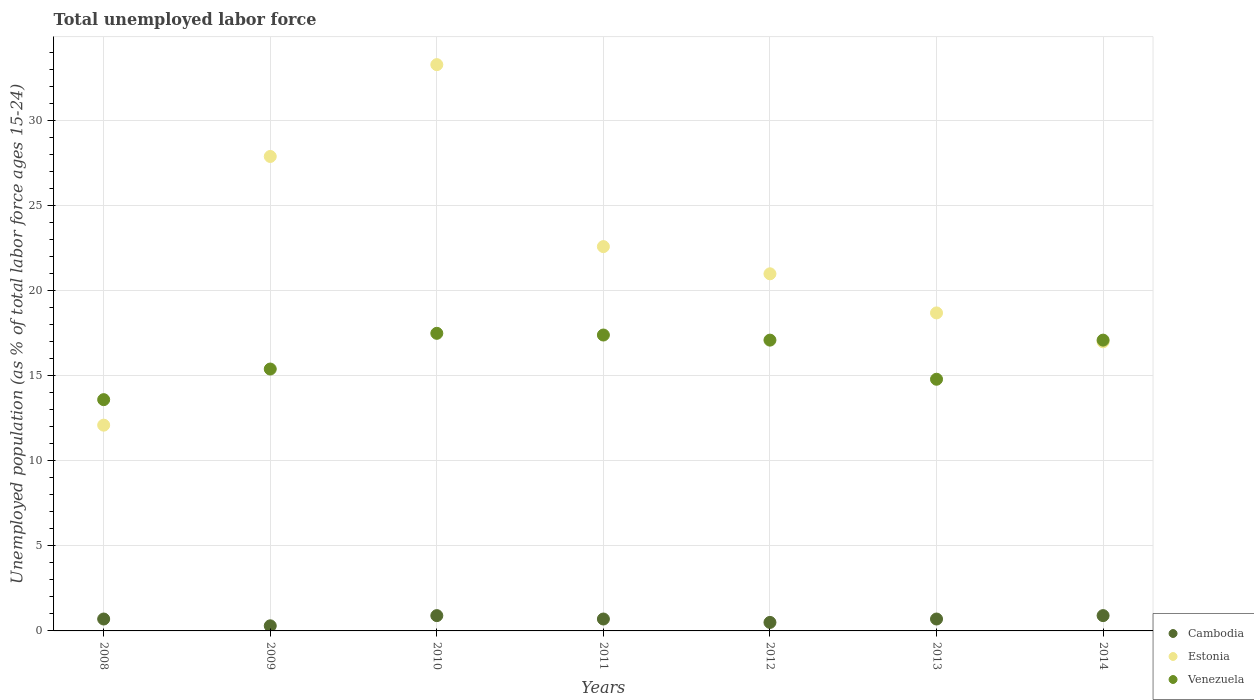Is the number of dotlines equal to the number of legend labels?
Offer a very short reply. Yes. Across all years, what is the maximum percentage of unemployed population in in Cambodia?
Offer a terse response. 0.9. Across all years, what is the minimum percentage of unemployed population in in Venezuela?
Provide a succinct answer. 13.6. In which year was the percentage of unemployed population in in Venezuela minimum?
Keep it short and to the point. 2008. What is the total percentage of unemployed population in in Estonia in the graph?
Offer a terse response. 152.6. What is the difference between the percentage of unemployed population in in Cambodia in 2009 and that in 2011?
Provide a succinct answer. -0.4. What is the difference between the percentage of unemployed population in in Estonia in 2008 and the percentage of unemployed population in in Venezuela in 2009?
Provide a short and direct response. -3.3. What is the average percentage of unemployed population in in Cambodia per year?
Keep it short and to the point. 0.67. In the year 2011, what is the difference between the percentage of unemployed population in in Venezuela and percentage of unemployed population in in Estonia?
Make the answer very short. -5.2. In how many years, is the percentage of unemployed population in in Venezuela greater than 12 %?
Provide a short and direct response. 7. What is the ratio of the percentage of unemployed population in in Cambodia in 2013 to that in 2014?
Provide a succinct answer. 0.78. Is the percentage of unemployed population in in Venezuela in 2011 less than that in 2012?
Make the answer very short. No. Is the difference between the percentage of unemployed population in in Venezuela in 2009 and 2010 greater than the difference between the percentage of unemployed population in in Estonia in 2009 and 2010?
Keep it short and to the point. Yes. What is the difference between the highest and the second highest percentage of unemployed population in in Cambodia?
Make the answer very short. 0. What is the difference between the highest and the lowest percentage of unemployed population in in Cambodia?
Your answer should be very brief. 0.6. In how many years, is the percentage of unemployed population in in Cambodia greater than the average percentage of unemployed population in in Cambodia taken over all years?
Your answer should be compact. 5. Is the sum of the percentage of unemployed population in in Estonia in 2010 and 2013 greater than the maximum percentage of unemployed population in in Venezuela across all years?
Keep it short and to the point. Yes. Is it the case that in every year, the sum of the percentage of unemployed population in in Venezuela and percentage of unemployed population in in Cambodia  is greater than the percentage of unemployed population in in Estonia?
Offer a very short reply. No. Is the percentage of unemployed population in in Venezuela strictly less than the percentage of unemployed population in in Cambodia over the years?
Ensure brevity in your answer.  No. How many years are there in the graph?
Provide a short and direct response. 7. What is the difference between two consecutive major ticks on the Y-axis?
Give a very brief answer. 5. Does the graph contain any zero values?
Offer a very short reply. No. Does the graph contain grids?
Ensure brevity in your answer.  Yes. Where does the legend appear in the graph?
Give a very brief answer. Bottom right. How are the legend labels stacked?
Your answer should be compact. Vertical. What is the title of the graph?
Make the answer very short. Total unemployed labor force. Does "Bahamas" appear as one of the legend labels in the graph?
Make the answer very short. No. What is the label or title of the X-axis?
Keep it short and to the point. Years. What is the label or title of the Y-axis?
Keep it short and to the point. Unemployed population (as % of total labor force ages 15-24). What is the Unemployed population (as % of total labor force ages 15-24) of Cambodia in 2008?
Your answer should be very brief. 0.7. What is the Unemployed population (as % of total labor force ages 15-24) of Estonia in 2008?
Make the answer very short. 12.1. What is the Unemployed population (as % of total labor force ages 15-24) of Venezuela in 2008?
Provide a succinct answer. 13.6. What is the Unemployed population (as % of total labor force ages 15-24) of Cambodia in 2009?
Provide a succinct answer. 0.3. What is the Unemployed population (as % of total labor force ages 15-24) of Estonia in 2009?
Offer a terse response. 27.9. What is the Unemployed population (as % of total labor force ages 15-24) of Venezuela in 2009?
Ensure brevity in your answer.  15.4. What is the Unemployed population (as % of total labor force ages 15-24) of Cambodia in 2010?
Offer a terse response. 0.9. What is the Unemployed population (as % of total labor force ages 15-24) in Estonia in 2010?
Ensure brevity in your answer.  33.3. What is the Unemployed population (as % of total labor force ages 15-24) of Venezuela in 2010?
Keep it short and to the point. 17.5. What is the Unemployed population (as % of total labor force ages 15-24) of Cambodia in 2011?
Keep it short and to the point. 0.7. What is the Unemployed population (as % of total labor force ages 15-24) in Estonia in 2011?
Keep it short and to the point. 22.6. What is the Unemployed population (as % of total labor force ages 15-24) in Venezuela in 2011?
Provide a succinct answer. 17.4. What is the Unemployed population (as % of total labor force ages 15-24) in Estonia in 2012?
Provide a succinct answer. 21. What is the Unemployed population (as % of total labor force ages 15-24) of Venezuela in 2012?
Give a very brief answer. 17.1. What is the Unemployed population (as % of total labor force ages 15-24) in Cambodia in 2013?
Give a very brief answer. 0.7. What is the Unemployed population (as % of total labor force ages 15-24) in Estonia in 2013?
Provide a succinct answer. 18.7. What is the Unemployed population (as % of total labor force ages 15-24) in Venezuela in 2013?
Your response must be concise. 14.8. What is the Unemployed population (as % of total labor force ages 15-24) in Cambodia in 2014?
Your response must be concise. 0.9. What is the Unemployed population (as % of total labor force ages 15-24) in Venezuela in 2014?
Your answer should be compact. 17.1. Across all years, what is the maximum Unemployed population (as % of total labor force ages 15-24) in Cambodia?
Your answer should be very brief. 0.9. Across all years, what is the maximum Unemployed population (as % of total labor force ages 15-24) in Estonia?
Provide a short and direct response. 33.3. Across all years, what is the maximum Unemployed population (as % of total labor force ages 15-24) in Venezuela?
Provide a succinct answer. 17.5. Across all years, what is the minimum Unemployed population (as % of total labor force ages 15-24) of Cambodia?
Provide a succinct answer. 0.3. Across all years, what is the minimum Unemployed population (as % of total labor force ages 15-24) in Estonia?
Offer a very short reply. 12.1. Across all years, what is the minimum Unemployed population (as % of total labor force ages 15-24) in Venezuela?
Your answer should be very brief. 13.6. What is the total Unemployed population (as % of total labor force ages 15-24) in Estonia in the graph?
Your answer should be very brief. 152.6. What is the total Unemployed population (as % of total labor force ages 15-24) in Venezuela in the graph?
Your answer should be very brief. 112.9. What is the difference between the Unemployed population (as % of total labor force ages 15-24) of Estonia in 2008 and that in 2009?
Your answer should be very brief. -15.8. What is the difference between the Unemployed population (as % of total labor force ages 15-24) in Estonia in 2008 and that in 2010?
Provide a succinct answer. -21.2. What is the difference between the Unemployed population (as % of total labor force ages 15-24) in Cambodia in 2008 and that in 2011?
Make the answer very short. 0. What is the difference between the Unemployed population (as % of total labor force ages 15-24) in Venezuela in 2008 and that in 2012?
Ensure brevity in your answer.  -3.5. What is the difference between the Unemployed population (as % of total labor force ages 15-24) of Estonia in 2008 and that in 2013?
Your answer should be very brief. -6.6. What is the difference between the Unemployed population (as % of total labor force ages 15-24) in Venezuela in 2008 and that in 2013?
Provide a short and direct response. -1.2. What is the difference between the Unemployed population (as % of total labor force ages 15-24) of Venezuela in 2008 and that in 2014?
Your answer should be compact. -3.5. What is the difference between the Unemployed population (as % of total labor force ages 15-24) of Estonia in 2009 and that in 2010?
Offer a very short reply. -5.4. What is the difference between the Unemployed population (as % of total labor force ages 15-24) of Venezuela in 2009 and that in 2010?
Provide a succinct answer. -2.1. What is the difference between the Unemployed population (as % of total labor force ages 15-24) of Cambodia in 2009 and that in 2011?
Keep it short and to the point. -0.4. What is the difference between the Unemployed population (as % of total labor force ages 15-24) of Estonia in 2009 and that in 2011?
Your answer should be very brief. 5.3. What is the difference between the Unemployed population (as % of total labor force ages 15-24) in Venezuela in 2009 and that in 2011?
Offer a terse response. -2. What is the difference between the Unemployed population (as % of total labor force ages 15-24) in Estonia in 2009 and that in 2012?
Offer a very short reply. 6.9. What is the difference between the Unemployed population (as % of total labor force ages 15-24) of Venezuela in 2009 and that in 2012?
Offer a terse response. -1.7. What is the difference between the Unemployed population (as % of total labor force ages 15-24) in Cambodia in 2009 and that in 2014?
Keep it short and to the point. -0.6. What is the difference between the Unemployed population (as % of total labor force ages 15-24) of Estonia in 2009 and that in 2014?
Your answer should be compact. 10.9. What is the difference between the Unemployed population (as % of total labor force ages 15-24) of Venezuela in 2009 and that in 2014?
Give a very brief answer. -1.7. What is the difference between the Unemployed population (as % of total labor force ages 15-24) of Cambodia in 2010 and that in 2011?
Make the answer very short. 0.2. What is the difference between the Unemployed population (as % of total labor force ages 15-24) in Estonia in 2010 and that in 2011?
Provide a succinct answer. 10.7. What is the difference between the Unemployed population (as % of total labor force ages 15-24) of Venezuela in 2010 and that in 2011?
Ensure brevity in your answer.  0.1. What is the difference between the Unemployed population (as % of total labor force ages 15-24) in Cambodia in 2010 and that in 2012?
Your response must be concise. 0.4. What is the difference between the Unemployed population (as % of total labor force ages 15-24) in Estonia in 2010 and that in 2012?
Your answer should be very brief. 12.3. What is the difference between the Unemployed population (as % of total labor force ages 15-24) of Venezuela in 2010 and that in 2012?
Keep it short and to the point. 0.4. What is the difference between the Unemployed population (as % of total labor force ages 15-24) of Cambodia in 2010 and that in 2013?
Offer a terse response. 0.2. What is the difference between the Unemployed population (as % of total labor force ages 15-24) of Estonia in 2010 and that in 2013?
Your answer should be very brief. 14.6. What is the difference between the Unemployed population (as % of total labor force ages 15-24) in Venezuela in 2010 and that in 2013?
Keep it short and to the point. 2.7. What is the difference between the Unemployed population (as % of total labor force ages 15-24) of Cambodia in 2010 and that in 2014?
Your answer should be very brief. 0. What is the difference between the Unemployed population (as % of total labor force ages 15-24) of Cambodia in 2011 and that in 2012?
Offer a very short reply. 0.2. What is the difference between the Unemployed population (as % of total labor force ages 15-24) in Estonia in 2011 and that in 2012?
Your answer should be compact. 1.6. What is the difference between the Unemployed population (as % of total labor force ages 15-24) of Cambodia in 2011 and that in 2013?
Provide a succinct answer. 0. What is the difference between the Unemployed population (as % of total labor force ages 15-24) of Estonia in 2011 and that in 2013?
Make the answer very short. 3.9. What is the difference between the Unemployed population (as % of total labor force ages 15-24) of Venezuela in 2011 and that in 2013?
Your response must be concise. 2.6. What is the difference between the Unemployed population (as % of total labor force ages 15-24) in Cambodia in 2011 and that in 2014?
Make the answer very short. -0.2. What is the difference between the Unemployed population (as % of total labor force ages 15-24) of Estonia in 2011 and that in 2014?
Offer a terse response. 5.6. What is the difference between the Unemployed population (as % of total labor force ages 15-24) of Venezuela in 2011 and that in 2014?
Your response must be concise. 0.3. What is the difference between the Unemployed population (as % of total labor force ages 15-24) in Venezuela in 2012 and that in 2013?
Provide a succinct answer. 2.3. What is the difference between the Unemployed population (as % of total labor force ages 15-24) in Cambodia in 2012 and that in 2014?
Offer a very short reply. -0.4. What is the difference between the Unemployed population (as % of total labor force ages 15-24) of Estonia in 2012 and that in 2014?
Offer a terse response. 4. What is the difference between the Unemployed population (as % of total labor force ages 15-24) in Venezuela in 2012 and that in 2014?
Ensure brevity in your answer.  0. What is the difference between the Unemployed population (as % of total labor force ages 15-24) in Cambodia in 2008 and the Unemployed population (as % of total labor force ages 15-24) in Estonia in 2009?
Your answer should be very brief. -27.2. What is the difference between the Unemployed population (as % of total labor force ages 15-24) of Cambodia in 2008 and the Unemployed population (as % of total labor force ages 15-24) of Venezuela in 2009?
Give a very brief answer. -14.7. What is the difference between the Unemployed population (as % of total labor force ages 15-24) in Cambodia in 2008 and the Unemployed population (as % of total labor force ages 15-24) in Estonia in 2010?
Make the answer very short. -32.6. What is the difference between the Unemployed population (as % of total labor force ages 15-24) of Cambodia in 2008 and the Unemployed population (as % of total labor force ages 15-24) of Venezuela in 2010?
Keep it short and to the point. -16.8. What is the difference between the Unemployed population (as % of total labor force ages 15-24) of Estonia in 2008 and the Unemployed population (as % of total labor force ages 15-24) of Venezuela in 2010?
Your answer should be very brief. -5.4. What is the difference between the Unemployed population (as % of total labor force ages 15-24) in Cambodia in 2008 and the Unemployed population (as % of total labor force ages 15-24) in Estonia in 2011?
Ensure brevity in your answer.  -21.9. What is the difference between the Unemployed population (as % of total labor force ages 15-24) of Cambodia in 2008 and the Unemployed population (as % of total labor force ages 15-24) of Venezuela in 2011?
Ensure brevity in your answer.  -16.7. What is the difference between the Unemployed population (as % of total labor force ages 15-24) in Estonia in 2008 and the Unemployed population (as % of total labor force ages 15-24) in Venezuela in 2011?
Ensure brevity in your answer.  -5.3. What is the difference between the Unemployed population (as % of total labor force ages 15-24) in Cambodia in 2008 and the Unemployed population (as % of total labor force ages 15-24) in Estonia in 2012?
Provide a succinct answer. -20.3. What is the difference between the Unemployed population (as % of total labor force ages 15-24) in Cambodia in 2008 and the Unemployed population (as % of total labor force ages 15-24) in Venezuela in 2012?
Provide a succinct answer. -16.4. What is the difference between the Unemployed population (as % of total labor force ages 15-24) in Cambodia in 2008 and the Unemployed population (as % of total labor force ages 15-24) in Venezuela in 2013?
Offer a very short reply. -14.1. What is the difference between the Unemployed population (as % of total labor force ages 15-24) in Cambodia in 2008 and the Unemployed population (as % of total labor force ages 15-24) in Estonia in 2014?
Provide a succinct answer. -16.3. What is the difference between the Unemployed population (as % of total labor force ages 15-24) of Cambodia in 2008 and the Unemployed population (as % of total labor force ages 15-24) of Venezuela in 2014?
Offer a very short reply. -16.4. What is the difference between the Unemployed population (as % of total labor force ages 15-24) in Estonia in 2008 and the Unemployed population (as % of total labor force ages 15-24) in Venezuela in 2014?
Keep it short and to the point. -5. What is the difference between the Unemployed population (as % of total labor force ages 15-24) of Cambodia in 2009 and the Unemployed population (as % of total labor force ages 15-24) of Estonia in 2010?
Give a very brief answer. -33. What is the difference between the Unemployed population (as % of total labor force ages 15-24) in Cambodia in 2009 and the Unemployed population (as % of total labor force ages 15-24) in Venezuela in 2010?
Give a very brief answer. -17.2. What is the difference between the Unemployed population (as % of total labor force ages 15-24) in Cambodia in 2009 and the Unemployed population (as % of total labor force ages 15-24) in Estonia in 2011?
Ensure brevity in your answer.  -22.3. What is the difference between the Unemployed population (as % of total labor force ages 15-24) of Cambodia in 2009 and the Unemployed population (as % of total labor force ages 15-24) of Venezuela in 2011?
Offer a terse response. -17.1. What is the difference between the Unemployed population (as % of total labor force ages 15-24) of Cambodia in 2009 and the Unemployed population (as % of total labor force ages 15-24) of Estonia in 2012?
Offer a very short reply. -20.7. What is the difference between the Unemployed population (as % of total labor force ages 15-24) of Cambodia in 2009 and the Unemployed population (as % of total labor force ages 15-24) of Venezuela in 2012?
Provide a short and direct response. -16.8. What is the difference between the Unemployed population (as % of total labor force ages 15-24) of Cambodia in 2009 and the Unemployed population (as % of total labor force ages 15-24) of Estonia in 2013?
Your answer should be compact. -18.4. What is the difference between the Unemployed population (as % of total labor force ages 15-24) in Cambodia in 2009 and the Unemployed population (as % of total labor force ages 15-24) in Estonia in 2014?
Provide a succinct answer. -16.7. What is the difference between the Unemployed population (as % of total labor force ages 15-24) in Cambodia in 2009 and the Unemployed population (as % of total labor force ages 15-24) in Venezuela in 2014?
Offer a terse response. -16.8. What is the difference between the Unemployed population (as % of total labor force ages 15-24) in Cambodia in 2010 and the Unemployed population (as % of total labor force ages 15-24) in Estonia in 2011?
Your answer should be compact. -21.7. What is the difference between the Unemployed population (as % of total labor force ages 15-24) in Cambodia in 2010 and the Unemployed population (as % of total labor force ages 15-24) in Venezuela in 2011?
Your answer should be compact. -16.5. What is the difference between the Unemployed population (as % of total labor force ages 15-24) of Estonia in 2010 and the Unemployed population (as % of total labor force ages 15-24) of Venezuela in 2011?
Give a very brief answer. 15.9. What is the difference between the Unemployed population (as % of total labor force ages 15-24) in Cambodia in 2010 and the Unemployed population (as % of total labor force ages 15-24) in Estonia in 2012?
Give a very brief answer. -20.1. What is the difference between the Unemployed population (as % of total labor force ages 15-24) of Cambodia in 2010 and the Unemployed population (as % of total labor force ages 15-24) of Venezuela in 2012?
Your answer should be very brief. -16.2. What is the difference between the Unemployed population (as % of total labor force ages 15-24) in Estonia in 2010 and the Unemployed population (as % of total labor force ages 15-24) in Venezuela in 2012?
Offer a terse response. 16.2. What is the difference between the Unemployed population (as % of total labor force ages 15-24) of Cambodia in 2010 and the Unemployed population (as % of total labor force ages 15-24) of Estonia in 2013?
Give a very brief answer. -17.8. What is the difference between the Unemployed population (as % of total labor force ages 15-24) in Cambodia in 2010 and the Unemployed population (as % of total labor force ages 15-24) in Venezuela in 2013?
Provide a short and direct response. -13.9. What is the difference between the Unemployed population (as % of total labor force ages 15-24) in Cambodia in 2010 and the Unemployed population (as % of total labor force ages 15-24) in Estonia in 2014?
Offer a terse response. -16.1. What is the difference between the Unemployed population (as % of total labor force ages 15-24) in Cambodia in 2010 and the Unemployed population (as % of total labor force ages 15-24) in Venezuela in 2014?
Keep it short and to the point. -16.2. What is the difference between the Unemployed population (as % of total labor force ages 15-24) in Cambodia in 2011 and the Unemployed population (as % of total labor force ages 15-24) in Estonia in 2012?
Your answer should be compact. -20.3. What is the difference between the Unemployed population (as % of total labor force ages 15-24) of Cambodia in 2011 and the Unemployed population (as % of total labor force ages 15-24) of Venezuela in 2012?
Offer a very short reply. -16.4. What is the difference between the Unemployed population (as % of total labor force ages 15-24) of Cambodia in 2011 and the Unemployed population (as % of total labor force ages 15-24) of Estonia in 2013?
Provide a short and direct response. -18. What is the difference between the Unemployed population (as % of total labor force ages 15-24) in Cambodia in 2011 and the Unemployed population (as % of total labor force ages 15-24) in Venezuela in 2013?
Your response must be concise. -14.1. What is the difference between the Unemployed population (as % of total labor force ages 15-24) of Estonia in 2011 and the Unemployed population (as % of total labor force ages 15-24) of Venezuela in 2013?
Your answer should be very brief. 7.8. What is the difference between the Unemployed population (as % of total labor force ages 15-24) of Cambodia in 2011 and the Unemployed population (as % of total labor force ages 15-24) of Estonia in 2014?
Provide a succinct answer. -16.3. What is the difference between the Unemployed population (as % of total labor force ages 15-24) of Cambodia in 2011 and the Unemployed population (as % of total labor force ages 15-24) of Venezuela in 2014?
Make the answer very short. -16.4. What is the difference between the Unemployed population (as % of total labor force ages 15-24) in Estonia in 2011 and the Unemployed population (as % of total labor force ages 15-24) in Venezuela in 2014?
Offer a very short reply. 5.5. What is the difference between the Unemployed population (as % of total labor force ages 15-24) in Cambodia in 2012 and the Unemployed population (as % of total labor force ages 15-24) in Estonia in 2013?
Provide a succinct answer. -18.2. What is the difference between the Unemployed population (as % of total labor force ages 15-24) of Cambodia in 2012 and the Unemployed population (as % of total labor force ages 15-24) of Venezuela in 2013?
Your response must be concise. -14.3. What is the difference between the Unemployed population (as % of total labor force ages 15-24) in Estonia in 2012 and the Unemployed population (as % of total labor force ages 15-24) in Venezuela in 2013?
Your answer should be compact. 6.2. What is the difference between the Unemployed population (as % of total labor force ages 15-24) of Cambodia in 2012 and the Unemployed population (as % of total labor force ages 15-24) of Estonia in 2014?
Keep it short and to the point. -16.5. What is the difference between the Unemployed population (as % of total labor force ages 15-24) in Cambodia in 2012 and the Unemployed population (as % of total labor force ages 15-24) in Venezuela in 2014?
Provide a succinct answer. -16.6. What is the difference between the Unemployed population (as % of total labor force ages 15-24) in Estonia in 2012 and the Unemployed population (as % of total labor force ages 15-24) in Venezuela in 2014?
Your response must be concise. 3.9. What is the difference between the Unemployed population (as % of total labor force ages 15-24) in Cambodia in 2013 and the Unemployed population (as % of total labor force ages 15-24) in Estonia in 2014?
Your response must be concise. -16.3. What is the difference between the Unemployed population (as % of total labor force ages 15-24) in Cambodia in 2013 and the Unemployed population (as % of total labor force ages 15-24) in Venezuela in 2014?
Make the answer very short. -16.4. What is the difference between the Unemployed population (as % of total labor force ages 15-24) of Estonia in 2013 and the Unemployed population (as % of total labor force ages 15-24) of Venezuela in 2014?
Offer a very short reply. 1.6. What is the average Unemployed population (as % of total labor force ages 15-24) of Cambodia per year?
Offer a very short reply. 0.67. What is the average Unemployed population (as % of total labor force ages 15-24) in Estonia per year?
Your answer should be very brief. 21.8. What is the average Unemployed population (as % of total labor force ages 15-24) of Venezuela per year?
Keep it short and to the point. 16.13. In the year 2008, what is the difference between the Unemployed population (as % of total labor force ages 15-24) of Cambodia and Unemployed population (as % of total labor force ages 15-24) of Estonia?
Offer a very short reply. -11.4. In the year 2009, what is the difference between the Unemployed population (as % of total labor force ages 15-24) of Cambodia and Unemployed population (as % of total labor force ages 15-24) of Estonia?
Ensure brevity in your answer.  -27.6. In the year 2009, what is the difference between the Unemployed population (as % of total labor force ages 15-24) of Cambodia and Unemployed population (as % of total labor force ages 15-24) of Venezuela?
Ensure brevity in your answer.  -15.1. In the year 2009, what is the difference between the Unemployed population (as % of total labor force ages 15-24) in Estonia and Unemployed population (as % of total labor force ages 15-24) in Venezuela?
Give a very brief answer. 12.5. In the year 2010, what is the difference between the Unemployed population (as % of total labor force ages 15-24) of Cambodia and Unemployed population (as % of total labor force ages 15-24) of Estonia?
Offer a very short reply. -32.4. In the year 2010, what is the difference between the Unemployed population (as % of total labor force ages 15-24) in Cambodia and Unemployed population (as % of total labor force ages 15-24) in Venezuela?
Your answer should be compact. -16.6. In the year 2010, what is the difference between the Unemployed population (as % of total labor force ages 15-24) of Estonia and Unemployed population (as % of total labor force ages 15-24) of Venezuela?
Offer a very short reply. 15.8. In the year 2011, what is the difference between the Unemployed population (as % of total labor force ages 15-24) in Cambodia and Unemployed population (as % of total labor force ages 15-24) in Estonia?
Make the answer very short. -21.9. In the year 2011, what is the difference between the Unemployed population (as % of total labor force ages 15-24) in Cambodia and Unemployed population (as % of total labor force ages 15-24) in Venezuela?
Your answer should be very brief. -16.7. In the year 2012, what is the difference between the Unemployed population (as % of total labor force ages 15-24) of Cambodia and Unemployed population (as % of total labor force ages 15-24) of Estonia?
Ensure brevity in your answer.  -20.5. In the year 2012, what is the difference between the Unemployed population (as % of total labor force ages 15-24) in Cambodia and Unemployed population (as % of total labor force ages 15-24) in Venezuela?
Offer a terse response. -16.6. In the year 2013, what is the difference between the Unemployed population (as % of total labor force ages 15-24) in Cambodia and Unemployed population (as % of total labor force ages 15-24) in Venezuela?
Provide a succinct answer. -14.1. In the year 2014, what is the difference between the Unemployed population (as % of total labor force ages 15-24) in Cambodia and Unemployed population (as % of total labor force ages 15-24) in Estonia?
Your answer should be very brief. -16.1. In the year 2014, what is the difference between the Unemployed population (as % of total labor force ages 15-24) in Cambodia and Unemployed population (as % of total labor force ages 15-24) in Venezuela?
Offer a terse response. -16.2. What is the ratio of the Unemployed population (as % of total labor force ages 15-24) in Cambodia in 2008 to that in 2009?
Your response must be concise. 2.33. What is the ratio of the Unemployed population (as % of total labor force ages 15-24) of Estonia in 2008 to that in 2009?
Your answer should be very brief. 0.43. What is the ratio of the Unemployed population (as % of total labor force ages 15-24) of Venezuela in 2008 to that in 2009?
Offer a very short reply. 0.88. What is the ratio of the Unemployed population (as % of total labor force ages 15-24) in Estonia in 2008 to that in 2010?
Provide a succinct answer. 0.36. What is the ratio of the Unemployed population (as % of total labor force ages 15-24) of Venezuela in 2008 to that in 2010?
Ensure brevity in your answer.  0.78. What is the ratio of the Unemployed population (as % of total labor force ages 15-24) of Cambodia in 2008 to that in 2011?
Keep it short and to the point. 1. What is the ratio of the Unemployed population (as % of total labor force ages 15-24) of Estonia in 2008 to that in 2011?
Make the answer very short. 0.54. What is the ratio of the Unemployed population (as % of total labor force ages 15-24) in Venezuela in 2008 to that in 2011?
Provide a succinct answer. 0.78. What is the ratio of the Unemployed population (as % of total labor force ages 15-24) of Cambodia in 2008 to that in 2012?
Your response must be concise. 1.4. What is the ratio of the Unemployed population (as % of total labor force ages 15-24) of Estonia in 2008 to that in 2012?
Ensure brevity in your answer.  0.58. What is the ratio of the Unemployed population (as % of total labor force ages 15-24) in Venezuela in 2008 to that in 2012?
Offer a terse response. 0.8. What is the ratio of the Unemployed population (as % of total labor force ages 15-24) of Cambodia in 2008 to that in 2013?
Make the answer very short. 1. What is the ratio of the Unemployed population (as % of total labor force ages 15-24) in Estonia in 2008 to that in 2013?
Your answer should be very brief. 0.65. What is the ratio of the Unemployed population (as % of total labor force ages 15-24) in Venezuela in 2008 to that in 2013?
Give a very brief answer. 0.92. What is the ratio of the Unemployed population (as % of total labor force ages 15-24) in Cambodia in 2008 to that in 2014?
Offer a terse response. 0.78. What is the ratio of the Unemployed population (as % of total labor force ages 15-24) of Estonia in 2008 to that in 2014?
Provide a short and direct response. 0.71. What is the ratio of the Unemployed population (as % of total labor force ages 15-24) of Venezuela in 2008 to that in 2014?
Your answer should be very brief. 0.8. What is the ratio of the Unemployed population (as % of total labor force ages 15-24) in Cambodia in 2009 to that in 2010?
Give a very brief answer. 0.33. What is the ratio of the Unemployed population (as % of total labor force ages 15-24) in Estonia in 2009 to that in 2010?
Offer a terse response. 0.84. What is the ratio of the Unemployed population (as % of total labor force ages 15-24) in Cambodia in 2009 to that in 2011?
Provide a succinct answer. 0.43. What is the ratio of the Unemployed population (as % of total labor force ages 15-24) in Estonia in 2009 to that in 2011?
Offer a terse response. 1.23. What is the ratio of the Unemployed population (as % of total labor force ages 15-24) of Venezuela in 2009 to that in 2011?
Keep it short and to the point. 0.89. What is the ratio of the Unemployed population (as % of total labor force ages 15-24) in Cambodia in 2009 to that in 2012?
Provide a short and direct response. 0.6. What is the ratio of the Unemployed population (as % of total labor force ages 15-24) in Estonia in 2009 to that in 2012?
Your answer should be compact. 1.33. What is the ratio of the Unemployed population (as % of total labor force ages 15-24) in Venezuela in 2009 to that in 2012?
Provide a short and direct response. 0.9. What is the ratio of the Unemployed population (as % of total labor force ages 15-24) in Cambodia in 2009 to that in 2013?
Provide a succinct answer. 0.43. What is the ratio of the Unemployed population (as % of total labor force ages 15-24) of Estonia in 2009 to that in 2013?
Your response must be concise. 1.49. What is the ratio of the Unemployed population (as % of total labor force ages 15-24) in Venezuela in 2009 to that in 2013?
Provide a succinct answer. 1.04. What is the ratio of the Unemployed population (as % of total labor force ages 15-24) of Estonia in 2009 to that in 2014?
Your answer should be very brief. 1.64. What is the ratio of the Unemployed population (as % of total labor force ages 15-24) of Venezuela in 2009 to that in 2014?
Provide a succinct answer. 0.9. What is the ratio of the Unemployed population (as % of total labor force ages 15-24) of Estonia in 2010 to that in 2011?
Ensure brevity in your answer.  1.47. What is the ratio of the Unemployed population (as % of total labor force ages 15-24) in Estonia in 2010 to that in 2012?
Provide a short and direct response. 1.59. What is the ratio of the Unemployed population (as % of total labor force ages 15-24) in Venezuela in 2010 to that in 2012?
Make the answer very short. 1.02. What is the ratio of the Unemployed population (as % of total labor force ages 15-24) in Estonia in 2010 to that in 2013?
Provide a succinct answer. 1.78. What is the ratio of the Unemployed population (as % of total labor force ages 15-24) of Venezuela in 2010 to that in 2013?
Make the answer very short. 1.18. What is the ratio of the Unemployed population (as % of total labor force ages 15-24) in Estonia in 2010 to that in 2014?
Keep it short and to the point. 1.96. What is the ratio of the Unemployed population (as % of total labor force ages 15-24) of Venezuela in 2010 to that in 2014?
Your answer should be very brief. 1.02. What is the ratio of the Unemployed population (as % of total labor force ages 15-24) of Cambodia in 2011 to that in 2012?
Ensure brevity in your answer.  1.4. What is the ratio of the Unemployed population (as % of total labor force ages 15-24) in Estonia in 2011 to that in 2012?
Offer a terse response. 1.08. What is the ratio of the Unemployed population (as % of total labor force ages 15-24) in Venezuela in 2011 to that in 2012?
Your answer should be compact. 1.02. What is the ratio of the Unemployed population (as % of total labor force ages 15-24) of Cambodia in 2011 to that in 2013?
Provide a short and direct response. 1. What is the ratio of the Unemployed population (as % of total labor force ages 15-24) of Estonia in 2011 to that in 2013?
Provide a short and direct response. 1.21. What is the ratio of the Unemployed population (as % of total labor force ages 15-24) of Venezuela in 2011 to that in 2013?
Give a very brief answer. 1.18. What is the ratio of the Unemployed population (as % of total labor force ages 15-24) in Estonia in 2011 to that in 2014?
Ensure brevity in your answer.  1.33. What is the ratio of the Unemployed population (as % of total labor force ages 15-24) of Venezuela in 2011 to that in 2014?
Your answer should be compact. 1.02. What is the ratio of the Unemployed population (as % of total labor force ages 15-24) in Cambodia in 2012 to that in 2013?
Make the answer very short. 0.71. What is the ratio of the Unemployed population (as % of total labor force ages 15-24) of Estonia in 2012 to that in 2013?
Make the answer very short. 1.12. What is the ratio of the Unemployed population (as % of total labor force ages 15-24) in Venezuela in 2012 to that in 2013?
Your response must be concise. 1.16. What is the ratio of the Unemployed population (as % of total labor force ages 15-24) in Cambodia in 2012 to that in 2014?
Provide a succinct answer. 0.56. What is the ratio of the Unemployed population (as % of total labor force ages 15-24) in Estonia in 2012 to that in 2014?
Make the answer very short. 1.24. What is the ratio of the Unemployed population (as % of total labor force ages 15-24) of Venezuela in 2012 to that in 2014?
Offer a very short reply. 1. What is the ratio of the Unemployed population (as % of total labor force ages 15-24) of Cambodia in 2013 to that in 2014?
Your answer should be very brief. 0.78. What is the ratio of the Unemployed population (as % of total labor force ages 15-24) of Venezuela in 2013 to that in 2014?
Your answer should be compact. 0.87. What is the difference between the highest and the lowest Unemployed population (as % of total labor force ages 15-24) of Estonia?
Your answer should be compact. 21.2. 